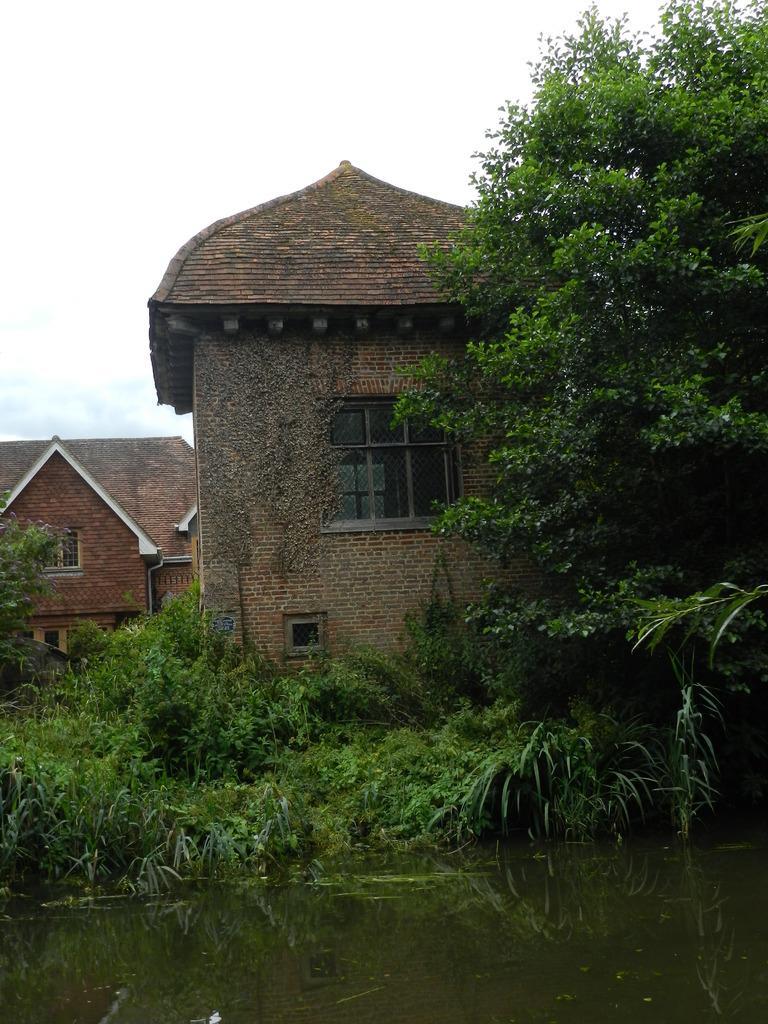How would you summarize this image in a sentence or two? In the image we can see the building and the windows of the building. We can even see the tree, grass, water and the sky. 